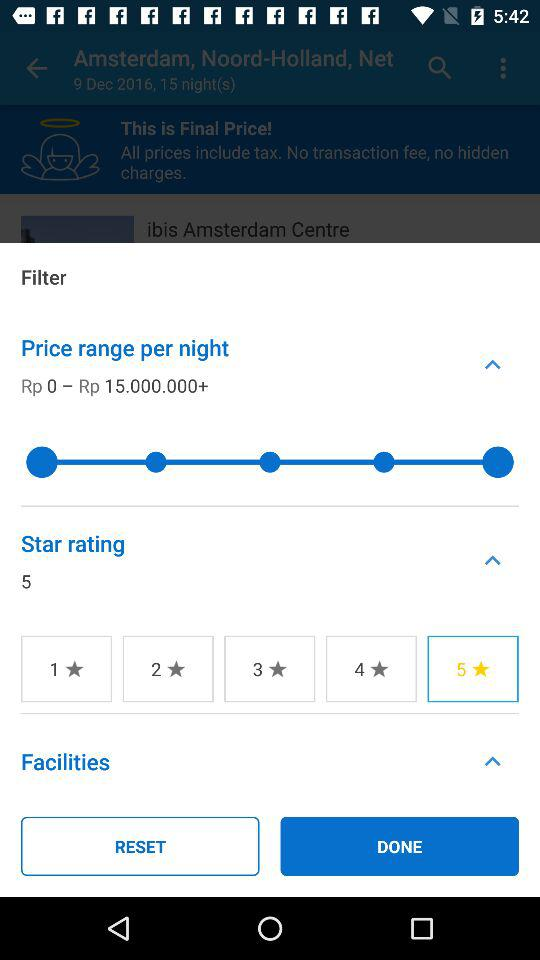What is the price range per night? The price range per night is Rp 0–Rp 15.000.000+. 